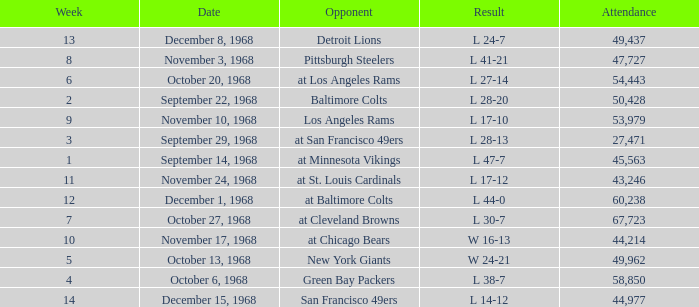Could you parse the entire table? {'header': ['Week', 'Date', 'Opponent', 'Result', 'Attendance'], 'rows': [['13', 'December 8, 1968', 'Detroit Lions', 'L 24-7', '49,437'], ['8', 'November 3, 1968', 'Pittsburgh Steelers', 'L 41-21', '47,727'], ['6', 'October 20, 1968', 'at Los Angeles Rams', 'L 27-14', '54,443'], ['2', 'September 22, 1968', 'Baltimore Colts', 'L 28-20', '50,428'], ['9', 'November 10, 1968', 'Los Angeles Rams', 'L 17-10', '53,979'], ['3', 'September 29, 1968', 'at San Francisco 49ers', 'L 28-13', '27,471'], ['1', 'September 14, 1968', 'at Minnesota Vikings', 'L 47-7', '45,563'], ['11', 'November 24, 1968', 'at St. Louis Cardinals', 'L 17-12', '43,246'], ['12', 'December 1, 1968', 'at Baltimore Colts', 'L 44-0', '60,238'], ['7', 'October 27, 1968', 'at Cleveland Browns', 'L 30-7', '67,723'], ['10', 'November 17, 1968', 'at Chicago Bears', 'W 16-13', '44,214'], ['5', 'October 13, 1968', 'New York Giants', 'W 24-21', '49,962'], ['4', 'October 6, 1968', 'Green Bay Packers', 'L 38-7', '58,850'], ['14', 'December 15, 1968', 'San Francisco 49ers', 'L 14-12', '44,977']]} Which Week has an Opponent of pittsburgh steelers, and an Attendance larger than 47,727? None. 